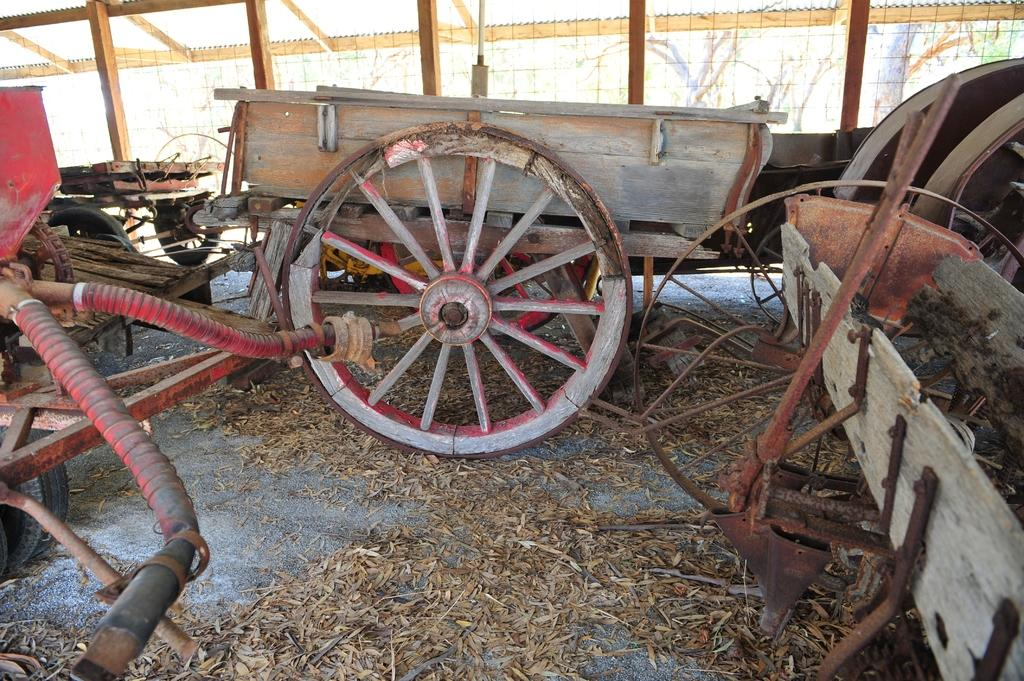What type of objects can be seen in the image? There are carts, wooden logs, and leaves in the image. Can you describe the wooden logs in the image? The wooden logs are visible in the image. What other unspecified objects can be seen in the image? There are other unspecified objects in the image. How many clocks are hanging from the carts in the image? There are no clocks visible in the image; it features carts, wooden logs, and leaves. What type of leg is supporting the carts in the image? There is no leg supporting the carts in the image; the carts are resting on the ground or another surface. 